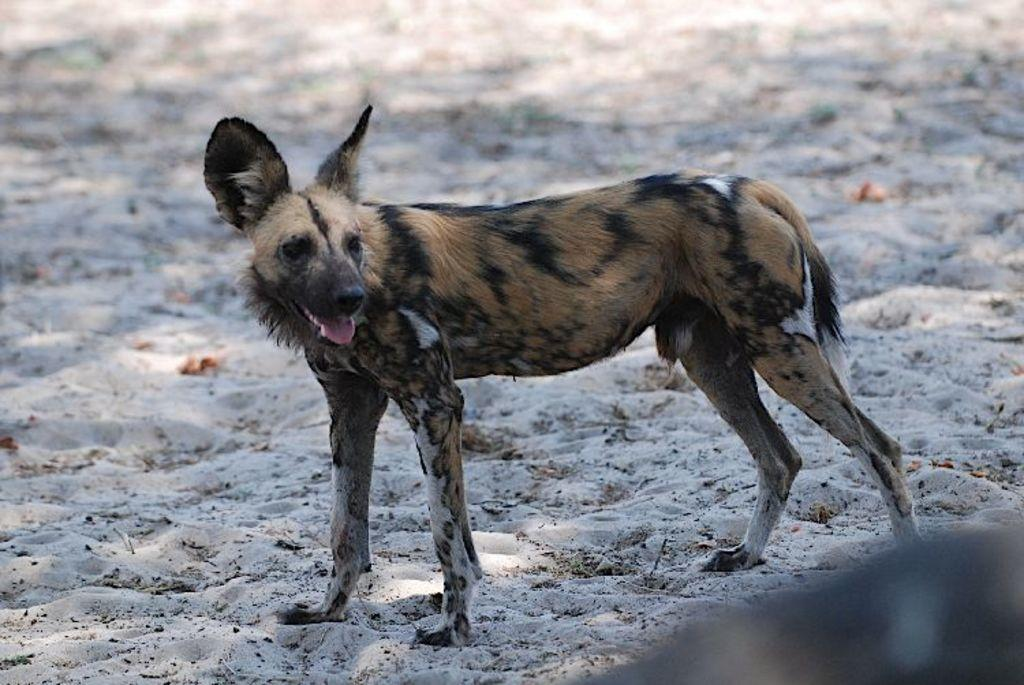What animal can be seen in the image? There is a dog in the image. Where is the dog positioned in the image? The dog is standing in the front. What type of surface is visible at the bottom of the image? There is sand at the bottom of the image. What is the purpose of the orange in the image? There is no orange present in the image, so it cannot serve any purpose within the context of the image. 